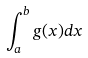Convert formula to latex. <formula><loc_0><loc_0><loc_500><loc_500>\int _ { a } ^ { b } g ( x ) d x</formula> 